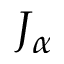Convert formula to latex. <formula><loc_0><loc_0><loc_500><loc_500>J _ { \alpha }</formula> 